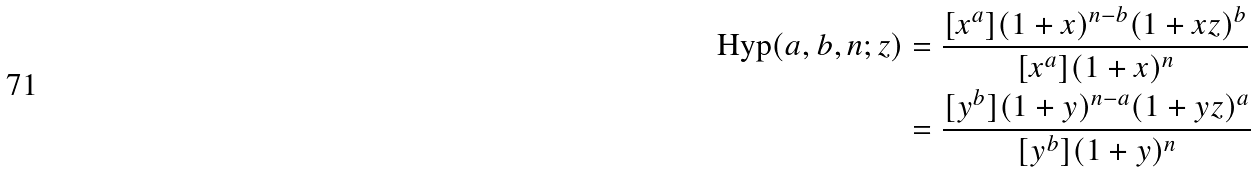Convert formula to latex. <formula><loc_0><loc_0><loc_500><loc_500>\text {Hyp} ( a , b , n ; z ) & = \frac { [ x ^ { a } ] ( 1 + x ) ^ { n - b } ( 1 + x z ) ^ { b } } { [ x ^ { a } ] ( 1 + x ) ^ { n } } \\ & = \frac { [ y ^ { b } ] ( 1 + y ) ^ { n - a } ( 1 + y z ) ^ { a } } { [ y ^ { b } ] ( 1 + y ) ^ { n } }</formula> 